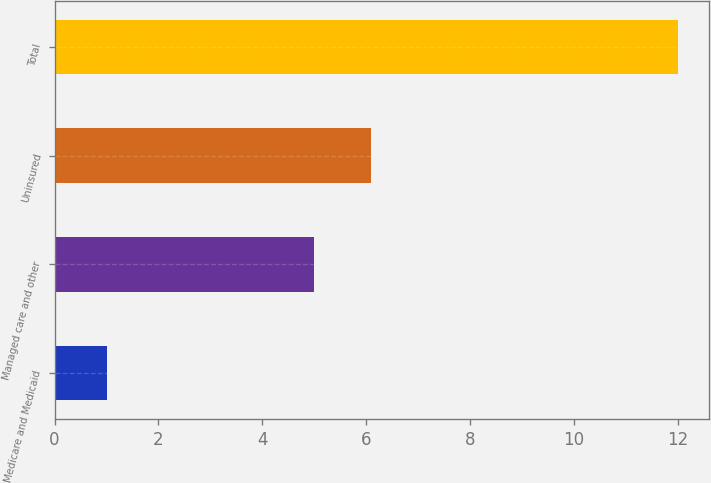<chart> <loc_0><loc_0><loc_500><loc_500><bar_chart><fcel>Medicare and Medicaid<fcel>Managed care and other<fcel>Uninsured<fcel>Total<nl><fcel>1<fcel>5<fcel>6.1<fcel>12<nl></chart> 